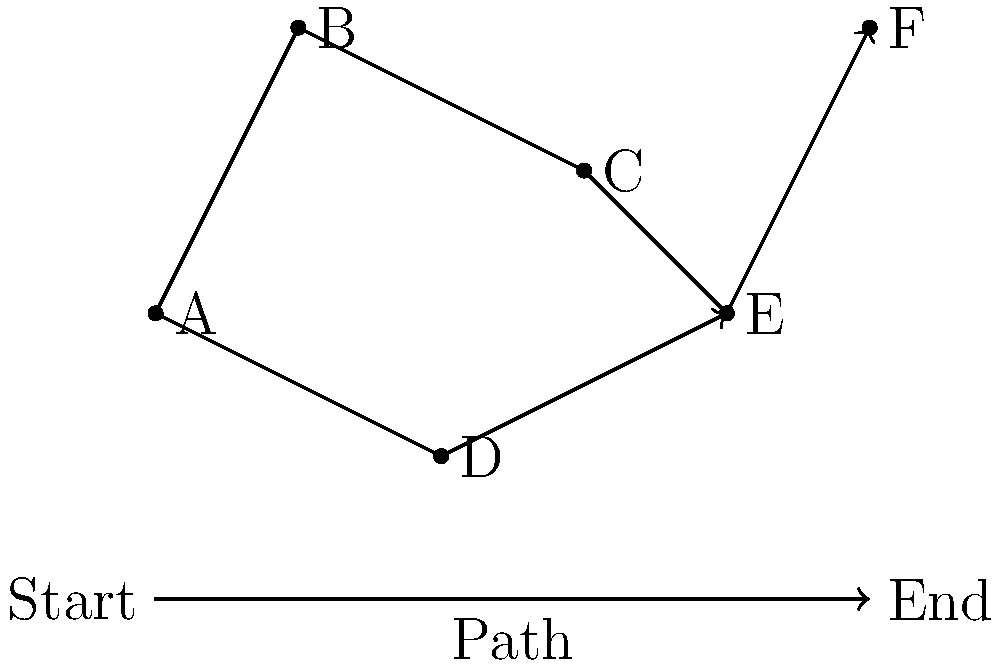In your spy-themed game, a covert operative needs to navigate through a city represented by the map above. The operative starts at point A and must reach point F while passing through specific checkpoints. Given that the operative must visit checkpoint C before checkpoint E, what is the minimum number of locations the operative must pass through (including start and end points) to complete the mission? To determine the minimum number of locations the operative must pass through, let's analyze the map and the given conditions:

1. The operative starts at point A (count: 1)
2. The operative must reach point F (this will be our last point)
3. The operative must visit checkpoint C before checkpoint E

Given these conditions, we can trace the path:

4. From A, the operative can go directly to B (count: 2)
5. From B, the operative must go to C as per the requirement (count: 3)
6. After C, the operative must visit E before F (count: 4)
7. Finally, the operative reaches F (count: 5)

The path A -> B -> C -> E -> F is the minimum path that satisfies all conditions. It passes through 5 locations in total.

Note that the alternative path through D is longer and unnecessary, as it doesn't help meet any of the requirements and would increase the number of locations visited.
Answer: 5 locations 